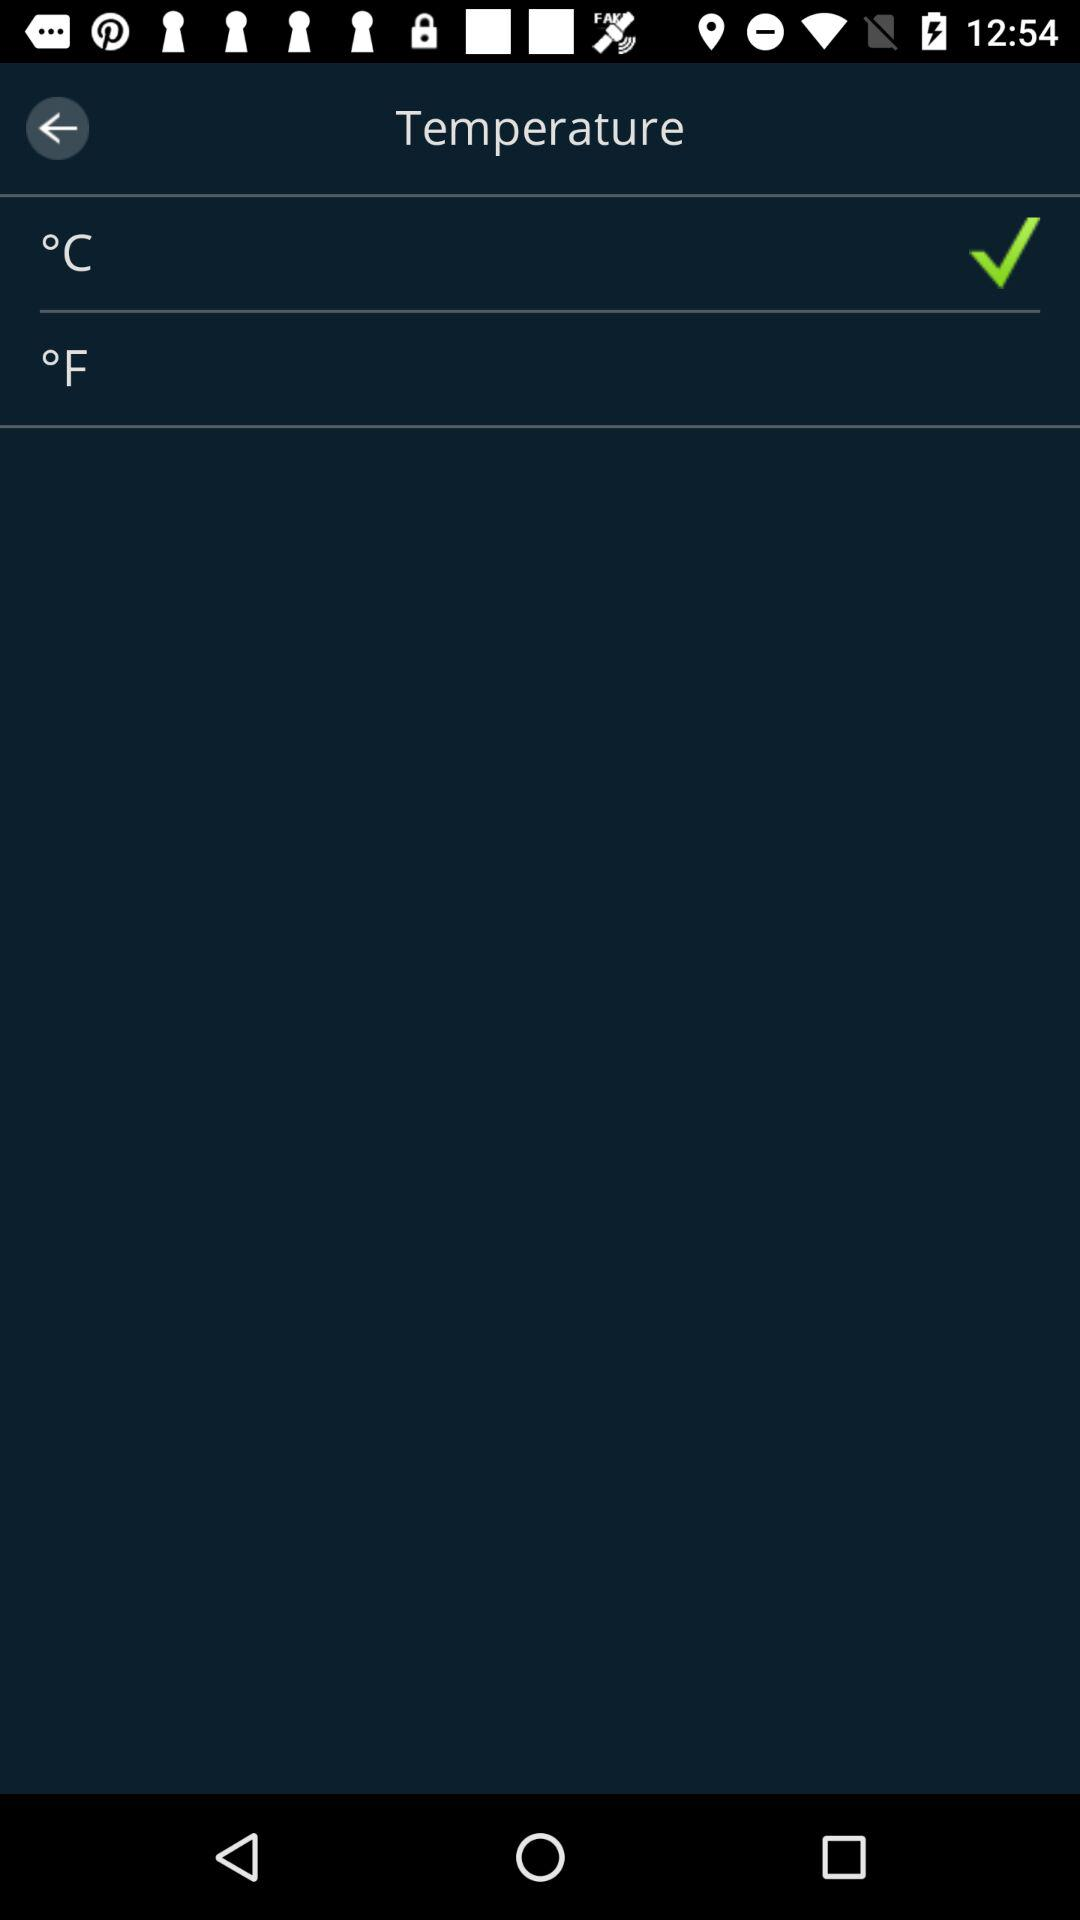Which temperature unit has the check mark?
Answer the question using a single word or phrase. °C 